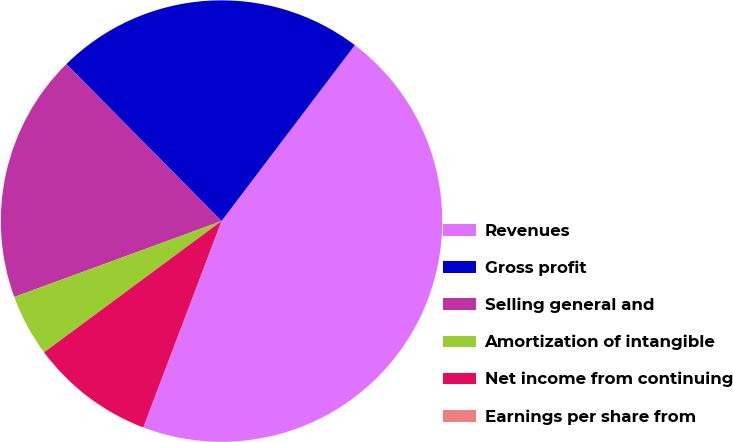Convert chart. <chart><loc_0><loc_0><loc_500><loc_500><pie_chart><fcel>Revenues<fcel>Gross profit<fcel>Selling general and<fcel>Amortization of intangible<fcel>Net income from continuing<fcel>Earnings per share from<nl><fcel>45.45%<fcel>22.73%<fcel>18.18%<fcel>4.55%<fcel>9.09%<fcel>0.0%<nl></chart> 